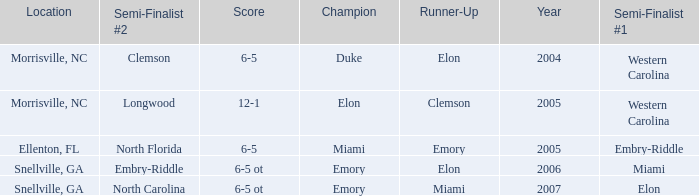Where was the final game played in 2007 Snellville, GA. 